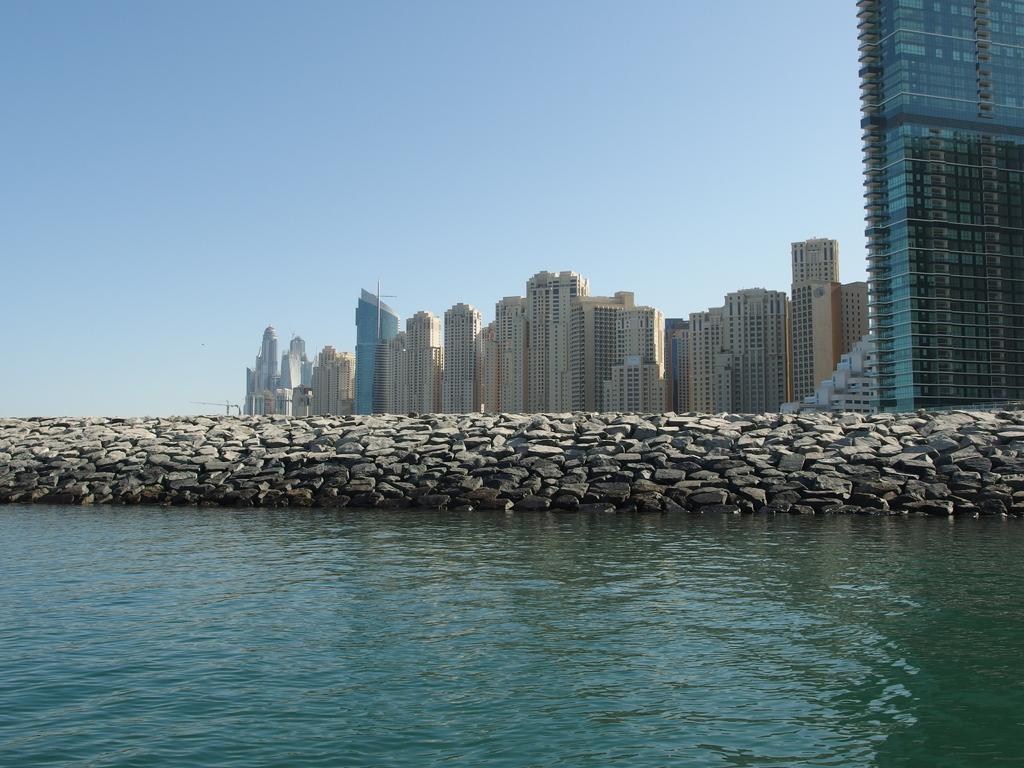How would you summarize this image in a sentence or two? In the image I can see a lake, rock wall and some buildings to the other side of the rock wall. 